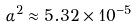<formula> <loc_0><loc_0><loc_500><loc_500>\alpha ^ { 2 } \approx 5 . 3 2 \times 1 0 ^ { - 5 }</formula> 